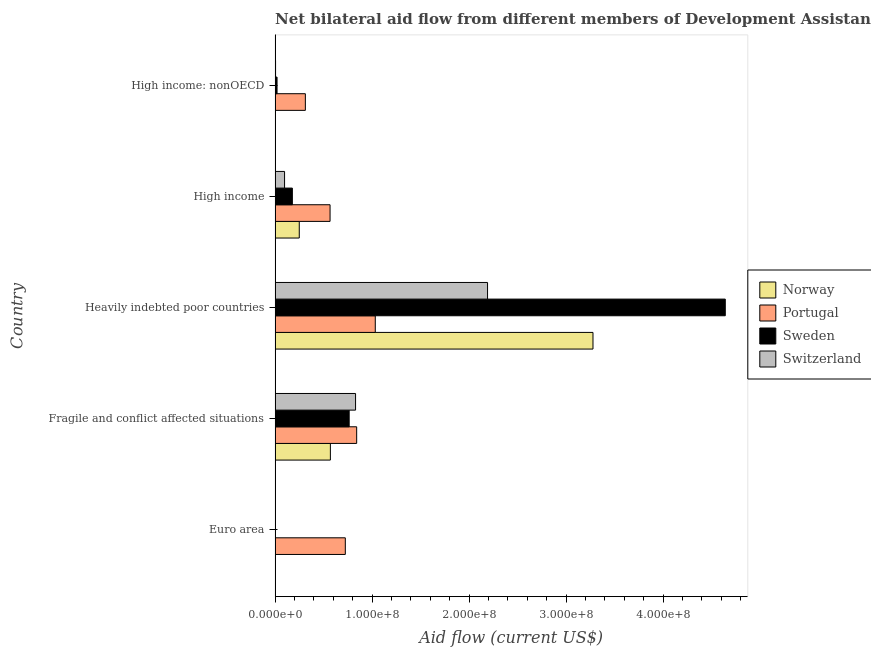How many different coloured bars are there?
Your answer should be compact. 4. Are the number of bars per tick equal to the number of legend labels?
Offer a terse response. Yes. Are the number of bars on each tick of the Y-axis equal?
Ensure brevity in your answer.  Yes. How many bars are there on the 4th tick from the bottom?
Make the answer very short. 4. What is the label of the 4th group of bars from the top?
Provide a short and direct response. Fragile and conflict affected situations. In how many cases, is the number of bars for a given country not equal to the number of legend labels?
Keep it short and to the point. 0. What is the amount of aid given by portugal in Euro area?
Offer a terse response. 7.24e+07. Across all countries, what is the maximum amount of aid given by sweden?
Your answer should be very brief. 4.64e+08. Across all countries, what is the minimum amount of aid given by portugal?
Offer a very short reply. 3.12e+07. In which country was the amount of aid given by sweden maximum?
Provide a succinct answer. Heavily indebted poor countries. What is the total amount of aid given by portugal in the graph?
Your answer should be compact. 3.48e+08. What is the difference between the amount of aid given by sweden in Euro area and that in Heavily indebted poor countries?
Ensure brevity in your answer.  -4.64e+08. What is the difference between the amount of aid given by sweden in High income: nonOECD and the amount of aid given by norway in Fragile and conflict affected situations?
Give a very brief answer. -5.50e+07. What is the average amount of aid given by portugal per country?
Your answer should be compact. 6.96e+07. What is the difference between the amount of aid given by norway and amount of aid given by portugal in Heavily indebted poor countries?
Provide a short and direct response. 2.24e+08. What is the ratio of the amount of aid given by portugal in Fragile and conflict affected situations to that in High income: nonOECD?
Give a very brief answer. 2.69. Is the difference between the amount of aid given by portugal in Euro area and Heavily indebted poor countries greater than the difference between the amount of aid given by switzerland in Euro area and Heavily indebted poor countries?
Your answer should be very brief. Yes. What is the difference between the highest and the second highest amount of aid given by switzerland?
Offer a very short reply. 1.36e+08. What is the difference between the highest and the lowest amount of aid given by portugal?
Your answer should be very brief. 7.21e+07. Is the sum of the amount of aid given by sweden in Fragile and conflict affected situations and High income: nonOECD greater than the maximum amount of aid given by norway across all countries?
Ensure brevity in your answer.  No. What does the 1st bar from the top in Euro area represents?
Your answer should be very brief. Switzerland. What does the 1st bar from the bottom in Fragile and conflict affected situations represents?
Keep it short and to the point. Norway. Is it the case that in every country, the sum of the amount of aid given by norway and amount of aid given by portugal is greater than the amount of aid given by sweden?
Make the answer very short. No. What is the difference between two consecutive major ticks on the X-axis?
Provide a short and direct response. 1.00e+08. Are the values on the major ticks of X-axis written in scientific E-notation?
Provide a succinct answer. Yes. Does the graph contain any zero values?
Your answer should be compact. No. Does the graph contain grids?
Keep it short and to the point. No. How many legend labels are there?
Give a very brief answer. 4. How are the legend labels stacked?
Make the answer very short. Vertical. What is the title of the graph?
Your response must be concise. Net bilateral aid flow from different members of Development Assistance Committee in the year 1990. Does "Corruption" appear as one of the legend labels in the graph?
Offer a terse response. No. What is the label or title of the X-axis?
Make the answer very short. Aid flow (current US$). What is the label or title of the Y-axis?
Your response must be concise. Country. What is the Aid flow (current US$) of Portugal in Euro area?
Your answer should be compact. 7.24e+07. What is the Aid flow (current US$) of Switzerland in Euro area?
Make the answer very short. 3.90e+05. What is the Aid flow (current US$) of Norway in Fragile and conflict affected situations?
Provide a succinct answer. 5.70e+07. What is the Aid flow (current US$) of Portugal in Fragile and conflict affected situations?
Your answer should be compact. 8.41e+07. What is the Aid flow (current US$) in Sweden in Fragile and conflict affected situations?
Keep it short and to the point. 7.64e+07. What is the Aid flow (current US$) in Switzerland in Fragile and conflict affected situations?
Your response must be concise. 8.30e+07. What is the Aid flow (current US$) in Norway in Heavily indebted poor countries?
Your answer should be very brief. 3.28e+08. What is the Aid flow (current US$) of Portugal in Heavily indebted poor countries?
Provide a succinct answer. 1.03e+08. What is the Aid flow (current US$) in Sweden in Heavily indebted poor countries?
Your answer should be very brief. 4.64e+08. What is the Aid flow (current US$) in Switzerland in Heavily indebted poor countries?
Make the answer very short. 2.19e+08. What is the Aid flow (current US$) in Norway in High income?
Make the answer very short. 2.49e+07. What is the Aid flow (current US$) in Portugal in High income?
Provide a short and direct response. 5.67e+07. What is the Aid flow (current US$) in Sweden in High income?
Provide a succinct answer. 1.78e+07. What is the Aid flow (current US$) in Switzerland in High income?
Make the answer very short. 9.78e+06. What is the Aid flow (current US$) of Norway in High income: nonOECD?
Provide a short and direct response. 5.00e+04. What is the Aid flow (current US$) in Portugal in High income: nonOECD?
Provide a short and direct response. 3.12e+07. What is the Aid flow (current US$) in Sweden in High income: nonOECD?
Your answer should be compact. 2.03e+06. What is the Aid flow (current US$) in Switzerland in High income: nonOECD?
Your answer should be very brief. 5.00e+05. Across all countries, what is the maximum Aid flow (current US$) in Norway?
Offer a very short reply. 3.28e+08. Across all countries, what is the maximum Aid flow (current US$) in Portugal?
Provide a short and direct response. 1.03e+08. Across all countries, what is the maximum Aid flow (current US$) in Sweden?
Your answer should be compact. 4.64e+08. Across all countries, what is the maximum Aid flow (current US$) in Switzerland?
Provide a succinct answer. 2.19e+08. Across all countries, what is the minimum Aid flow (current US$) of Portugal?
Your response must be concise. 3.12e+07. Across all countries, what is the minimum Aid flow (current US$) of Sweden?
Your response must be concise. 10000. Across all countries, what is the minimum Aid flow (current US$) in Switzerland?
Keep it short and to the point. 3.90e+05. What is the total Aid flow (current US$) of Norway in the graph?
Offer a very short reply. 4.10e+08. What is the total Aid flow (current US$) in Portugal in the graph?
Ensure brevity in your answer.  3.48e+08. What is the total Aid flow (current US$) of Sweden in the graph?
Make the answer very short. 5.60e+08. What is the total Aid flow (current US$) of Switzerland in the graph?
Offer a terse response. 3.13e+08. What is the difference between the Aid flow (current US$) of Norway in Euro area and that in Fragile and conflict affected situations?
Provide a short and direct response. -5.66e+07. What is the difference between the Aid flow (current US$) of Portugal in Euro area and that in Fragile and conflict affected situations?
Keep it short and to the point. -1.17e+07. What is the difference between the Aid flow (current US$) in Sweden in Euro area and that in Fragile and conflict affected situations?
Keep it short and to the point. -7.64e+07. What is the difference between the Aid flow (current US$) of Switzerland in Euro area and that in Fragile and conflict affected situations?
Provide a succinct answer. -8.26e+07. What is the difference between the Aid flow (current US$) of Norway in Euro area and that in Heavily indebted poor countries?
Your answer should be compact. -3.27e+08. What is the difference between the Aid flow (current US$) of Portugal in Euro area and that in Heavily indebted poor countries?
Offer a terse response. -3.09e+07. What is the difference between the Aid flow (current US$) of Sweden in Euro area and that in Heavily indebted poor countries?
Your answer should be compact. -4.64e+08. What is the difference between the Aid flow (current US$) of Switzerland in Euro area and that in Heavily indebted poor countries?
Offer a terse response. -2.19e+08. What is the difference between the Aid flow (current US$) in Norway in Euro area and that in High income?
Make the answer very short. -2.45e+07. What is the difference between the Aid flow (current US$) of Portugal in Euro area and that in High income?
Offer a terse response. 1.57e+07. What is the difference between the Aid flow (current US$) in Sweden in Euro area and that in High income?
Provide a short and direct response. -1.78e+07. What is the difference between the Aid flow (current US$) of Switzerland in Euro area and that in High income?
Offer a very short reply. -9.39e+06. What is the difference between the Aid flow (current US$) in Norway in Euro area and that in High income: nonOECD?
Make the answer very short. 3.80e+05. What is the difference between the Aid flow (current US$) in Portugal in Euro area and that in High income: nonOECD?
Keep it short and to the point. 4.12e+07. What is the difference between the Aid flow (current US$) in Sweden in Euro area and that in High income: nonOECD?
Offer a terse response. -2.02e+06. What is the difference between the Aid flow (current US$) of Norway in Fragile and conflict affected situations and that in Heavily indebted poor countries?
Offer a very short reply. -2.71e+08. What is the difference between the Aid flow (current US$) of Portugal in Fragile and conflict affected situations and that in Heavily indebted poor countries?
Your answer should be compact. -1.92e+07. What is the difference between the Aid flow (current US$) of Sweden in Fragile and conflict affected situations and that in Heavily indebted poor countries?
Ensure brevity in your answer.  -3.88e+08. What is the difference between the Aid flow (current US$) in Switzerland in Fragile and conflict affected situations and that in Heavily indebted poor countries?
Offer a terse response. -1.36e+08. What is the difference between the Aid flow (current US$) in Norway in Fragile and conflict affected situations and that in High income?
Make the answer very short. 3.21e+07. What is the difference between the Aid flow (current US$) in Portugal in Fragile and conflict affected situations and that in High income?
Provide a succinct answer. 2.74e+07. What is the difference between the Aid flow (current US$) in Sweden in Fragile and conflict affected situations and that in High income?
Provide a succinct answer. 5.86e+07. What is the difference between the Aid flow (current US$) in Switzerland in Fragile and conflict affected situations and that in High income?
Your answer should be compact. 7.32e+07. What is the difference between the Aid flow (current US$) in Norway in Fragile and conflict affected situations and that in High income: nonOECD?
Provide a short and direct response. 5.70e+07. What is the difference between the Aid flow (current US$) of Portugal in Fragile and conflict affected situations and that in High income: nonOECD?
Your response must be concise. 5.29e+07. What is the difference between the Aid flow (current US$) in Sweden in Fragile and conflict affected situations and that in High income: nonOECD?
Your answer should be very brief. 7.44e+07. What is the difference between the Aid flow (current US$) in Switzerland in Fragile and conflict affected situations and that in High income: nonOECD?
Your response must be concise. 8.25e+07. What is the difference between the Aid flow (current US$) of Norway in Heavily indebted poor countries and that in High income?
Give a very brief answer. 3.03e+08. What is the difference between the Aid flow (current US$) of Portugal in Heavily indebted poor countries and that in High income?
Your answer should be very brief. 4.66e+07. What is the difference between the Aid flow (current US$) of Sweden in Heavily indebted poor countries and that in High income?
Make the answer very short. 4.46e+08. What is the difference between the Aid flow (current US$) of Switzerland in Heavily indebted poor countries and that in High income?
Give a very brief answer. 2.09e+08. What is the difference between the Aid flow (current US$) in Norway in Heavily indebted poor countries and that in High income: nonOECD?
Keep it short and to the point. 3.28e+08. What is the difference between the Aid flow (current US$) in Portugal in Heavily indebted poor countries and that in High income: nonOECD?
Your answer should be very brief. 7.21e+07. What is the difference between the Aid flow (current US$) in Sweden in Heavily indebted poor countries and that in High income: nonOECD?
Your response must be concise. 4.62e+08. What is the difference between the Aid flow (current US$) of Switzerland in Heavily indebted poor countries and that in High income: nonOECD?
Provide a short and direct response. 2.19e+08. What is the difference between the Aid flow (current US$) in Norway in High income and that in High income: nonOECD?
Offer a terse response. 2.49e+07. What is the difference between the Aid flow (current US$) of Portugal in High income and that in High income: nonOECD?
Ensure brevity in your answer.  2.55e+07. What is the difference between the Aid flow (current US$) in Sweden in High income and that in High income: nonOECD?
Provide a short and direct response. 1.58e+07. What is the difference between the Aid flow (current US$) in Switzerland in High income and that in High income: nonOECD?
Offer a terse response. 9.28e+06. What is the difference between the Aid flow (current US$) of Norway in Euro area and the Aid flow (current US$) of Portugal in Fragile and conflict affected situations?
Your answer should be very brief. -8.37e+07. What is the difference between the Aid flow (current US$) of Norway in Euro area and the Aid flow (current US$) of Sweden in Fragile and conflict affected situations?
Your answer should be very brief. -7.60e+07. What is the difference between the Aid flow (current US$) in Norway in Euro area and the Aid flow (current US$) in Switzerland in Fragile and conflict affected situations?
Your answer should be compact. -8.26e+07. What is the difference between the Aid flow (current US$) of Portugal in Euro area and the Aid flow (current US$) of Sweden in Fragile and conflict affected situations?
Your response must be concise. -3.98e+06. What is the difference between the Aid flow (current US$) of Portugal in Euro area and the Aid flow (current US$) of Switzerland in Fragile and conflict affected situations?
Your answer should be compact. -1.06e+07. What is the difference between the Aid flow (current US$) in Sweden in Euro area and the Aid flow (current US$) in Switzerland in Fragile and conflict affected situations?
Give a very brief answer. -8.30e+07. What is the difference between the Aid flow (current US$) in Norway in Euro area and the Aid flow (current US$) in Portugal in Heavily indebted poor countries?
Ensure brevity in your answer.  -1.03e+08. What is the difference between the Aid flow (current US$) of Norway in Euro area and the Aid flow (current US$) of Sweden in Heavily indebted poor countries?
Ensure brevity in your answer.  -4.64e+08. What is the difference between the Aid flow (current US$) of Norway in Euro area and the Aid flow (current US$) of Switzerland in Heavily indebted poor countries?
Ensure brevity in your answer.  -2.19e+08. What is the difference between the Aid flow (current US$) of Portugal in Euro area and the Aid flow (current US$) of Sweden in Heavily indebted poor countries?
Your response must be concise. -3.92e+08. What is the difference between the Aid flow (current US$) in Portugal in Euro area and the Aid flow (current US$) in Switzerland in Heavily indebted poor countries?
Your answer should be very brief. -1.47e+08. What is the difference between the Aid flow (current US$) of Sweden in Euro area and the Aid flow (current US$) of Switzerland in Heavily indebted poor countries?
Provide a short and direct response. -2.19e+08. What is the difference between the Aid flow (current US$) in Norway in Euro area and the Aid flow (current US$) in Portugal in High income?
Ensure brevity in your answer.  -5.63e+07. What is the difference between the Aid flow (current US$) in Norway in Euro area and the Aid flow (current US$) in Sweden in High income?
Your answer should be very brief. -1.74e+07. What is the difference between the Aid flow (current US$) of Norway in Euro area and the Aid flow (current US$) of Switzerland in High income?
Give a very brief answer. -9.35e+06. What is the difference between the Aid flow (current US$) of Portugal in Euro area and the Aid flow (current US$) of Sweden in High income?
Provide a short and direct response. 5.46e+07. What is the difference between the Aid flow (current US$) in Portugal in Euro area and the Aid flow (current US$) in Switzerland in High income?
Your answer should be compact. 6.26e+07. What is the difference between the Aid flow (current US$) in Sweden in Euro area and the Aid flow (current US$) in Switzerland in High income?
Your response must be concise. -9.77e+06. What is the difference between the Aid flow (current US$) in Norway in Euro area and the Aid flow (current US$) in Portugal in High income: nonOECD?
Ensure brevity in your answer.  -3.08e+07. What is the difference between the Aid flow (current US$) of Norway in Euro area and the Aid flow (current US$) of Sweden in High income: nonOECD?
Make the answer very short. -1.60e+06. What is the difference between the Aid flow (current US$) in Norway in Euro area and the Aid flow (current US$) in Switzerland in High income: nonOECD?
Make the answer very short. -7.00e+04. What is the difference between the Aid flow (current US$) of Portugal in Euro area and the Aid flow (current US$) of Sweden in High income: nonOECD?
Your answer should be very brief. 7.04e+07. What is the difference between the Aid flow (current US$) in Portugal in Euro area and the Aid flow (current US$) in Switzerland in High income: nonOECD?
Offer a terse response. 7.19e+07. What is the difference between the Aid flow (current US$) in Sweden in Euro area and the Aid flow (current US$) in Switzerland in High income: nonOECD?
Ensure brevity in your answer.  -4.90e+05. What is the difference between the Aid flow (current US$) in Norway in Fragile and conflict affected situations and the Aid flow (current US$) in Portugal in Heavily indebted poor countries?
Make the answer very short. -4.63e+07. What is the difference between the Aid flow (current US$) of Norway in Fragile and conflict affected situations and the Aid flow (current US$) of Sweden in Heavily indebted poor countries?
Your answer should be compact. -4.07e+08. What is the difference between the Aid flow (current US$) of Norway in Fragile and conflict affected situations and the Aid flow (current US$) of Switzerland in Heavily indebted poor countries?
Offer a terse response. -1.62e+08. What is the difference between the Aid flow (current US$) in Portugal in Fragile and conflict affected situations and the Aid flow (current US$) in Sweden in Heavily indebted poor countries?
Ensure brevity in your answer.  -3.80e+08. What is the difference between the Aid flow (current US$) of Portugal in Fragile and conflict affected situations and the Aid flow (current US$) of Switzerland in Heavily indebted poor countries?
Provide a short and direct response. -1.35e+08. What is the difference between the Aid flow (current US$) of Sweden in Fragile and conflict affected situations and the Aid flow (current US$) of Switzerland in Heavily indebted poor countries?
Offer a terse response. -1.43e+08. What is the difference between the Aid flow (current US$) in Norway in Fragile and conflict affected situations and the Aid flow (current US$) in Portugal in High income?
Make the answer very short. 3.10e+05. What is the difference between the Aid flow (current US$) in Norway in Fragile and conflict affected situations and the Aid flow (current US$) in Sweden in High income?
Your answer should be compact. 3.92e+07. What is the difference between the Aid flow (current US$) of Norway in Fragile and conflict affected situations and the Aid flow (current US$) of Switzerland in High income?
Ensure brevity in your answer.  4.72e+07. What is the difference between the Aid flow (current US$) in Portugal in Fragile and conflict affected situations and the Aid flow (current US$) in Sweden in High income?
Your answer should be compact. 6.63e+07. What is the difference between the Aid flow (current US$) of Portugal in Fragile and conflict affected situations and the Aid flow (current US$) of Switzerland in High income?
Offer a very short reply. 7.44e+07. What is the difference between the Aid flow (current US$) of Sweden in Fragile and conflict affected situations and the Aid flow (current US$) of Switzerland in High income?
Provide a succinct answer. 6.66e+07. What is the difference between the Aid flow (current US$) of Norway in Fragile and conflict affected situations and the Aid flow (current US$) of Portugal in High income: nonOECD?
Provide a short and direct response. 2.58e+07. What is the difference between the Aid flow (current US$) in Norway in Fragile and conflict affected situations and the Aid flow (current US$) in Sweden in High income: nonOECD?
Keep it short and to the point. 5.50e+07. What is the difference between the Aid flow (current US$) of Norway in Fragile and conflict affected situations and the Aid flow (current US$) of Switzerland in High income: nonOECD?
Make the answer very short. 5.65e+07. What is the difference between the Aid flow (current US$) of Portugal in Fragile and conflict affected situations and the Aid flow (current US$) of Sweden in High income: nonOECD?
Make the answer very short. 8.21e+07. What is the difference between the Aid flow (current US$) in Portugal in Fragile and conflict affected situations and the Aid flow (current US$) in Switzerland in High income: nonOECD?
Ensure brevity in your answer.  8.36e+07. What is the difference between the Aid flow (current US$) in Sweden in Fragile and conflict affected situations and the Aid flow (current US$) in Switzerland in High income: nonOECD?
Your answer should be very brief. 7.59e+07. What is the difference between the Aid flow (current US$) in Norway in Heavily indebted poor countries and the Aid flow (current US$) in Portugal in High income?
Ensure brevity in your answer.  2.71e+08. What is the difference between the Aid flow (current US$) in Norway in Heavily indebted poor countries and the Aid flow (current US$) in Sweden in High income?
Your answer should be compact. 3.10e+08. What is the difference between the Aid flow (current US$) in Norway in Heavily indebted poor countries and the Aid flow (current US$) in Switzerland in High income?
Your response must be concise. 3.18e+08. What is the difference between the Aid flow (current US$) of Portugal in Heavily indebted poor countries and the Aid flow (current US$) of Sweden in High income?
Your answer should be very brief. 8.55e+07. What is the difference between the Aid flow (current US$) in Portugal in Heavily indebted poor countries and the Aid flow (current US$) in Switzerland in High income?
Ensure brevity in your answer.  9.35e+07. What is the difference between the Aid flow (current US$) of Sweden in Heavily indebted poor countries and the Aid flow (current US$) of Switzerland in High income?
Provide a succinct answer. 4.54e+08. What is the difference between the Aid flow (current US$) of Norway in Heavily indebted poor countries and the Aid flow (current US$) of Portugal in High income: nonOECD?
Your answer should be compact. 2.97e+08. What is the difference between the Aid flow (current US$) of Norway in Heavily indebted poor countries and the Aid flow (current US$) of Sweden in High income: nonOECD?
Offer a very short reply. 3.26e+08. What is the difference between the Aid flow (current US$) of Norway in Heavily indebted poor countries and the Aid flow (current US$) of Switzerland in High income: nonOECD?
Make the answer very short. 3.27e+08. What is the difference between the Aid flow (current US$) in Portugal in Heavily indebted poor countries and the Aid flow (current US$) in Sweden in High income: nonOECD?
Provide a short and direct response. 1.01e+08. What is the difference between the Aid flow (current US$) of Portugal in Heavily indebted poor countries and the Aid flow (current US$) of Switzerland in High income: nonOECD?
Offer a very short reply. 1.03e+08. What is the difference between the Aid flow (current US$) in Sweden in Heavily indebted poor countries and the Aid flow (current US$) in Switzerland in High income: nonOECD?
Your response must be concise. 4.64e+08. What is the difference between the Aid flow (current US$) of Norway in High income and the Aid flow (current US$) of Portugal in High income: nonOECD?
Ensure brevity in your answer.  -6.28e+06. What is the difference between the Aid flow (current US$) of Norway in High income and the Aid flow (current US$) of Sweden in High income: nonOECD?
Ensure brevity in your answer.  2.29e+07. What is the difference between the Aid flow (current US$) of Norway in High income and the Aid flow (current US$) of Switzerland in High income: nonOECD?
Your response must be concise. 2.44e+07. What is the difference between the Aid flow (current US$) in Portugal in High income and the Aid flow (current US$) in Sweden in High income: nonOECD?
Keep it short and to the point. 5.47e+07. What is the difference between the Aid flow (current US$) of Portugal in High income and the Aid flow (current US$) of Switzerland in High income: nonOECD?
Give a very brief answer. 5.62e+07. What is the difference between the Aid flow (current US$) of Sweden in High income and the Aid flow (current US$) of Switzerland in High income: nonOECD?
Your answer should be compact. 1.73e+07. What is the average Aid flow (current US$) of Norway per country?
Keep it short and to the point. 8.20e+07. What is the average Aid flow (current US$) in Portugal per country?
Your answer should be compact. 6.96e+07. What is the average Aid flow (current US$) in Sweden per country?
Give a very brief answer. 1.12e+08. What is the average Aid flow (current US$) in Switzerland per country?
Keep it short and to the point. 6.25e+07. What is the difference between the Aid flow (current US$) of Norway and Aid flow (current US$) of Portugal in Euro area?
Offer a very short reply. -7.20e+07. What is the difference between the Aid flow (current US$) of Norway and Aid flow (current US$) of Sweden in Euro area?
Ensure brevity in your answer.  4.20e+05. What is the difference between the Aid flow (current US$) in Portugal and Aid flow (current US$) in Sweden in Euro area?
Provide a succinct answer. 7.24e+07. What is the difference between the Aid flow (current US$) of Portugal and Aid flow (current US$) of Switzerland in Euro area?
Provide a succinct answer. 7.20e+07. What is the difference between the Aid flow (current US$) in Sweden and Aid flow (current US$) in Switzerland in Euro area?
Provide a succinct answer. -3.80e+05. What is the difference between the Aid flow (current US$) in Norway and Aid flow (current US$) in Portugal in Fragile and conflict affected situations?
Ensure brevity in your answer.  -2.71e+07. What is the difference between the Aid flow (current US$) of Norway and Aid flow (current US$) of Sweden in Fragile and conflict affected situations?
Keep it short and to the point. -1.94e+07. What is the difference between the Aid flow (current US$) of Norway and Aid flow (current US$) of Switzerland in Fragile and conflict affected situations?
Offer a very short reply. -2.60e+07. What is the difference between the Aid flow (current US$) in Portugal and Aid flow (current US$) in Sweden in Fragile and conflict affected situations?
Give a very brief answer. 7.73e+06. What is the difference between the Aid flow (current US$) of Portugal and Aid flow (current US$) of Switzerland in Fragile and conflict affected situations?
Provide a succinct answer. 1.15e+06. What is the difference between the Aid flow (current US$) in Sweden and Aid flow (current US$) in Switzerland in Fragile and conflict affected situations?
Your answer should be compact. -6.58e+06. What is the difference between the Aid flow (current US$) in Norway and Aid flow (current US$) in Portugal in Heavily indebted poor countries?
Your response must be concise. 2.24e+08. What is the difference between the Aid flow (current US$) of Norway and Aid flow (current US$) of Sweden in Heavily indebted poor countries?
Provide a short and direct response. -1.36e+08. What is the difference between the Aid flow (current US$) of Norway and Aid flow (current US$) of Switzerland in Heavily indebted poor countries?
Provide a succinct answer. 1.09e+08. What is the difference between the Aid flow (current US$) in Portugal and Aid flow (current US$) in Sweden in Heavily indebted poor countries?
Make the answer very short. -3.61e+08. What is the difference between the Aid flow (current US$) in Portugal and Aid flow (current US$) in Switzerland in Heavily indebted poor countries?
Make the answer very short. -1.16e+08. What is the difference between the Aid flow (current US$) of Sweden and Aid flow (current US$) of Switzerland in Heavily indebted poor countries?
Your answer should be compact. 2.45e+08. What is the difference between the Aid flow (current US$) in Norway and Aid flow (current US$) in Portugal in High income?
Make the answer very short. -3.18e+07. What is the difference between the Aid flow (current US$) in Norway and Aid flow (current US$) in Sweden in High income?
Provide a succinct answer. 7.13e+06. What is the difference between the Aid flow (current US$) of Norway and Aid flow (current US$) of Switzerland in High income?
Ensure brevity in your answer.  1.52e+07. What is the difference between the Aid flow (current US$) in Portugal and Aid flow (current US$) in Sweden in High income?
Offer a terse response. 3.89e+07. What is the difference between the Aid flow (current US$) in Portugal and Aid flow (current US$) in Switzerland in High income?
Keep it short and to the point. 4.69e+07. What is the difference between the Aid flow (current US$) of Sweden and Aid flow (current US$) of Switzerland in High income?
Make the answer very short. 8.03e+06. What is the difference between the Aid flow (current US$) in Norway and Aid flow (current US$) in Portugal in High income: nonOECD?
Provide a short and direct response. -3.12e+07. What is the difference between the Aid flow (current US$) of Norway and Aid flow (current US$) of Sweden in High income: nonOECD?
Offer a very short reply. -1.98e+06. What is the difference between the Aid flow (current US$) of Norway and Aid flow (current US$) of Switzerland in High income: nonOECD?
Offer a very short reply. -4.50e+05. What is the difference between the Aid flow (current US$) of Portugal and Aid flow (current US$) of Sweden in High income: nonOECD?
Your response must be concise. 2.92e+07. What is the difference between the Aid flow (current US$) in Portugal and Aid flow (current US$) in Switzerland in High income: nonOECD?
Ensure brevity in your answer.  3.07e+07. What is the difference between the Aid flow (current US$) in Sweden and Aid flow (current US$) in Switzerland in High income: nonOECD?
Ensure brevity in your answer.  1.53e+06. What is the ratio of the Aid flow (current US$) in Norway in Euro area to that in Fragile and conflict affected situations?
Make the answer very short. 0.01. What is the ratio of the Aid flow (current US$) of Portugal in Euro area to that in Fragile and conflict affected situations?
Your answer should be compact. 0.86. What is the ratio of the Aid flow (current US$) in Switzerland in Euro area to that in Fragile and conflict affected situations?
Provide a succinct answer. 0. What is the ratio of the Aid flow (current US$) of Norway in Euro area to that in Heavily indebted poor countries?
Provide a succinct answer. 0. What is the ratio of the Aid flow (current US$) in Portugal in Euro area to that in Heavily indebted poor countries?
Keep it short and to the point. 0.7. What is the ratio of the Aid flow (current US$) of Switzerland in Euro area to that in Heavily indebted poor countries?
Ensure brevity in your answer.  0. What is the ratio of the Aid flow (current US$) in Norway in Euro area to that in High income?
Provide a short and direct response. 0.02. What is the ratio of the Aid flow (current US$) of Portugal in Euro area to that in High income?
Offer a terse response. 1.28. What is the ratio of the Aid flow (current US$) in Sweden in Euro area to that in High income?
Provide a short and direct response. 0. What is the ratio of the Aid flow (current US$) of Switzerland in Euro area to that in High income?
Provide a succinct answer. 0.04. What is the ratio of the Aid flow (current US$) of Portugal in Euro area to that in High income: nonOECD?
Your answer should be compact. 2.32. What is the ratio of the Aid flow (current US$) of Sweden in Euro area to that in High income: nonOECD?
Offer a very short reply. 0. What is the ratio of the Aid flow (current US$) of Switzerland in Euro area to that in High income: nonOECD?
Ensure brevity in your answer.  0.78. What is the ratio of the Aid flow (current US$) of Norway in Fragile and conflict affected situations to that in Heavily indebted poor countries?
Your answer should be compact. 0.17. What is the ratio of the Aid flow (current US$) of Portugal in Fragile and conflict affected situations to that in Heavily indebted poor countries?
Your response must be concise. 0.81. What is the ratio of the Aid flow (current US$) of Sweden in Fragile and conflict affected situations to that in Heavily indebted poor countries?
Give a very brief answer. 0.16. What is the ratio of the Aid flow (current US$) of Switzerland in Fragile and conflict affected situations to that in Heavily indebted poor countries?
Your response must be concise. 0.38. What is the ratio of the Aid flow (current US$) in Norway in Fragile and conflict affected situations to that in High income?
Your response must be concise. 2.29. What is the ratio of the Aid flow (current US$) of Portugal in Fragile and conflict affected situations to that in High income?
Provide a short and direct response. 1.48. What is the ratio of the Aid flow (current US$) of Sweden in Fragile and conflict affected situations to that in High income?
Offer a terse response. 4.29. What is the ratio of the Aid flow (current US$) in Switzerland in Fragile and conflict affected situations to that in High income?
Your response must be concise. 8.48. What is the ratio of the Aid flow (current US$) of Norway in Fragile and conflict affected situations to that in High income: nonOECD?
Offer a very short reply. 1140.2. What is the ratio of the Aid flow (current US$) of Portugal in Fragile and conflict affected situations to that in High income: nonOECD?
Provide a succinct answer. 2.69. What is the ratio of the Aid flow (current US$) of Sweden in Fragile and conflict affected situations to that in High income: nonOECD?
Offer a very short reply. 37.64. What is the ratio of the Aid flow (current US$) of Switzerland in Fragile and conflict affected situations to that in High income: nonOECD?
Your answer should be compact. 165.96. What is the ratio of the Aid flow (current US$) of Norway in Heavily indebted poor countries to that in High income?
Your response must be concise. 13.14. What is the ratio of the Aid flow (current US$) in Portugal in Heavily indebted poor countries to that in High income?
Your answer should be compact. 1.82. What is the ratio of the Aid flow (current US$) in Sweden in Heavily indebted poor countries to that in High income?
Make the answer very short. 26.06. What is the ratio of the Aid flow (current US$) in Switzerland in Heavily indebted poor countries to that in High income?
Ensure brevity in your answer.  22.4. What is the ratio of the Aid flow (current US$) in Norway in Heavily indebted poor countries to that in High income: nonOECD?
Ensure brevity in your answer.  6555.8. What is the ratio of the Aid flow (current US$) of Portugal in Heavily indebted poor countries to that in High income: nonOECD?
Provide a succinct answer. 3.31. What is the ratio of the Aid flow (current US$) of Sweden in Heavily indebted poor countries to that in High income: nonOECD?
Your answer should be compact. 228.67. What is the ratio of the Aid flow (current US$) in Switzerland in Heavily indebted poor countries to that in High income: nonOECD?
Make the answer very short. 438.14. What is the ratio of the Aid flow (current US$) in Norway in High income to that in High income: nonOECD?
Provide a succinct answer. 498.8. What is the ratio of the Aid flow (current US$) in Portugal in High income to that in High income: nonOECD?
Keep it short and to the point. 1.82. What is the ratio of the Aid flow (current US$) of Sweden in High income to that in High income: nonOECD?
Ensure brevity in your answer.  8.77. What is the ratio of the Aid flow (current US$) of Switzerland in High income to that in High income: nonOECD?
Your response must be concise. 19.56. What is the difference between the highest and the second highest Aid flow (current US$) of Norway?
Offer a terse response. 2.71e+08. What is the difference between the highest and the second highest Aid flow (current US$) of Portugal?
Your response must be concise. 1.92e+07. What is the difference between the highest and the second highest Aid flow (current US$) of Sweden?
Give a very brief answer. 3.88e+08. What is the difference between the highest and the second highest Aid flow (current US$) in Switzerland?
Offer a terse response. 1.36e+08. What is the difference between the highest and the lowest Aid flow (current US$) of Norway?
Provide a succinct answer. 3.28e+08. What is the difference between the highest and the lowest Aid flow (current US$) of Portugal?
Your response must be concise. 7.21e+07. What is the difference between the highest and the lowest Aid flow (current US$) in Sweden?
Provide a succinct answer. 4.64e+08. What is the difference between the highest and the lowest Aid flow (current US$) in Switzerland?
Your answer should be compact. 2.19e+08. 